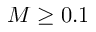<formula> <loc_0><loc_0><loc_500><loc_500>M \geq 0 . 1</formula> 